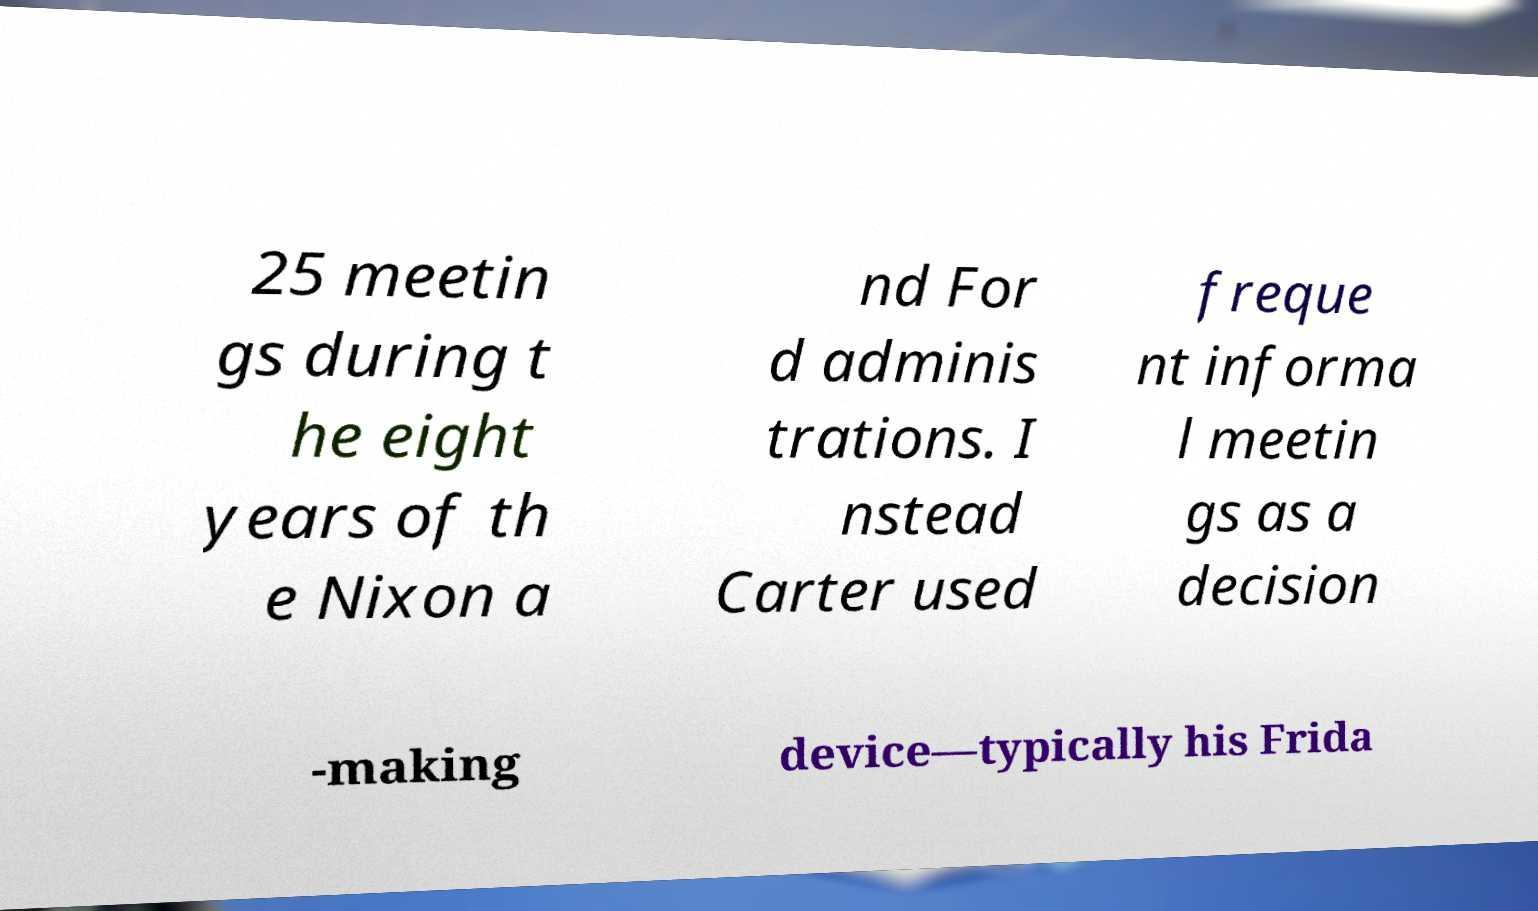I need the written content from this picture converted into text. Can you do that? 25 meetin gs during t he eight years of th e Nixon a nd For d adminis trations. I nstead Carter used freque nt informa l meetin gs as a decision -making device—typically his Frida 